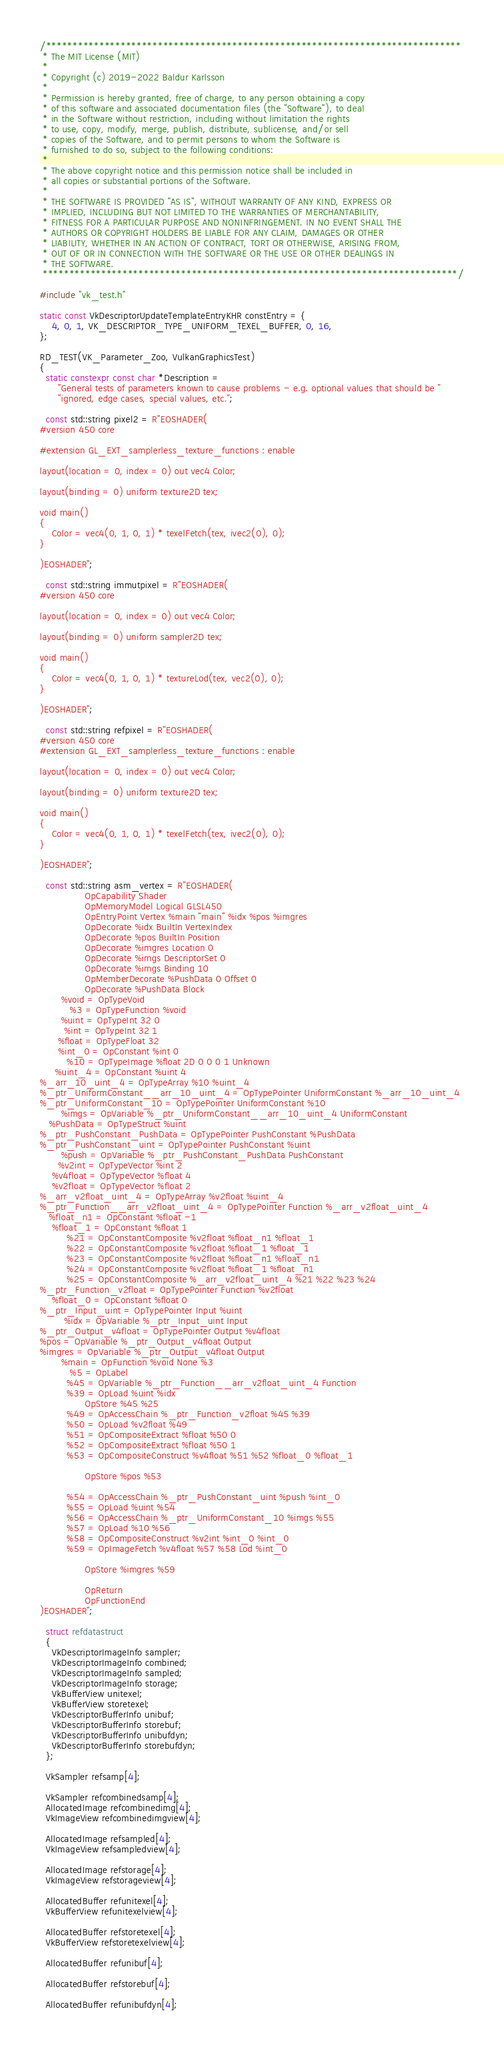<code> <loc_0><loc_0><loc_500><loc_500><_C++_>/******************************************************************************
 * The MIT License (MIT)
 *
 * Copyright (c) 2019-2022 Baldur Karlsson
 *
 * Permission is hereby granted, free of charge, to any person obtaining a copy
 * of this software and associated documentation files (the "Software"), to deal
 * in the Software without restriction, including without limitation the rights
 * to use, copy, modify, merge, publish, distribute, sublicense, and/or sell
 * copies of the Software, and to permit persons to whom the Software is
 * furnished to do so, subject to the following conditions:
 *
 * The above copyright notice and this permission notice shall be included in
 * all copies or substantial portions of the Software.
 *
 * THE SOFTWARE IS PROVIDED "AS IS", WITHOUT WARRANTY OF ANY KIND, EXPRESS OR
 * IMPLIED, INCLUDING BUT NOT LIMITED TO THE WARRANTIES OF MERCHANTABILITY,
 * FITNESS FOR A PARTICULAR PURPOSE AND NONINFRINGEMENT. IN NO EVENT SHALL THE
 * AUTHORS OR COPYRIGHT HOLDERS BE LIABLE FOR ANY CLAIM, DAMAGES OR OTHER
 * LIABILITY, WHETHER IN AN ACTION OF CONTRACT, TORT OR OTHERWISE, ARISING FROM,
 * OUT OF OR IN CONNECTION WITH THE SOFTWARE OR THE USE OR OTHER DEALINGS IN
 * THE SOFTWARE.
 ******************************************************************************/

#include "vk_test.h"

static const VkDescriptorUpdateTemplateEntryKHR constEntry = {
    4, 0, 1, VK_DESCRIPTOR_TYPE_UNIFORM_TEXEL_BUFFER, 0, 16,
};

RD_TEST(VK_Parameter_Zoo, VulkanGraphicsTest)
{
  static constexpr const char *Description =
      "General tests of parameters known to cause problems - e.g. optional values that should be "
      "ignored, edge cases, special values, etc.";

  const std::string pixel2 = R"EOSHADER(
#version 450 core

#extension GL_EXT_samplerless_texture_functions : enable

layout(location = 0, index = 0) out vec4 Color;

layout(binding = 0) uniform texture2D tex;

void main()
{
	Color = vec4(0, 1, 0, 1) * texelFetch(tex, ivec2(0), 0);
}

)EOSHADER";

  const std::string immutpixel = R"EOSHADER(
#version 450 core

layout(location = 0, index = 0) out vec4 Color;

layout(binding = 0) uniform sampler2D tex;

void main()
{
	Color = vec4(0, 1, 0, 1) * textureLod(tex, vec2(0), 0);
}

)EOSHADER";

  const std::string refpixel = R"EOSHADER(
#version 450 core
#extension GL_EXT_samplerless_texture_functions : enable

layout(location = 0, index = 0) out vec4 Color;

layout(binding = 0) uniform texture2D tex;

void main()
{
	Color = vec4(0, 1, 0, 1) * texelFetch(tex, ivec2(0), 0);
}

)EOSHADER";

  const std::string asm_vertex = R"EOSHADER(
               OpCapability Shader
               OpMemoryModel Logical GLSL450
               OpEntryPoint Vertex %main "main" %idx %pos %imgres
               OpDecorate %idx BuiltIn VertexIndex
               OpDecorate %pos BuiltIn Position
               OpDecorate %imgres Location 0
               OpDecorate %imgs DescriptorSet 0
               OpDecorate %imgs Binding 10
               OpMemberDecorate %PushData 0 Offset 0
               OpDecorate %PushData Block
       %void = OpTypeVoid
          %3 = OpTypeFunction %void
       %uint = OpTypeInt 32 0
        %int = OpTypeInt 32 1
      %float = OpTypeFloat 32
      %int_0 = OpConstant %int 0
         %10 = OpTypeImage %float 2D 0 0 0 1 Unknown
     %uint_4 = OpConstant %uint 4
%_arr_10_uint_4 = OpTypeArray %10 %uint_4
%_ptr_UniformConstant__arr_10_uint_4 = OpTypePointer UniformConstant %_arr_10_uint_4
%_ptr_UniformConstant_10 = OpTypePointer UniformConstant %10
       %imgs = OpVariable %_ptr_UniformConstant__arr_10_uint_4 UniformConstant
   %PushData = OpTypeStruct %uint
%_ptr_PushConstant_PushData = OpTypePointer PushConstant %PushData
%_ptr_PushConstant_uint = OpTypePointer PushConstant %uint
       %push = OpVariable %_ptr_PushConstant_PushData PushConstant
      %v2int = OpTypeVector %int 2
    %v4float = OpTypeVector %float 4
    %v2float = OpTypeVector %float 2
%_arr_v2float_uint_4 = OpTypeArray %v2float %uint_4
%_ptr_Function__arr_v2float_uint_4 = OpTypePointer Function %_arr_v2float_uint_4
   %float_n1 = OpConstant %float -1
    %float_1 = OpConstant %float 1
         %21 = OpConstantComposite %v2float %float_n1 %float_1
         %22 = OpConstantComposite %v2float %float_1 %float_1
         %23 = OpConstantComposite %v2float %float_n1 %float_n1
         %24 = OpConstantComposite %v2float %float_1 %float_n1
         %25 = OpConstantComposite %_arr_v2float_uint_4 %21 %22 %23 %24
%_ptr_Function_v2float = OpTypePointer Function %v2float
    %float_0 = OpConstant %float 0
%_ptr_Input_uint = OpTypePointer Input %uint
        %idx = OpVariable %_ptr_Input_uint Input
%_ptr_Output_v4float = OpTypePointer Output %v4float
%pos = OpVariable %_ptr_Output_v4float Output
%imgres = OpVariable %_ptr_Output_v4float Output
       %main = OpFunction %void None %3
          %5 = OpLabel
         %45 = OpVariable %_ptr_Function__arr_v2float_uint_4 Function
         %39 = OpLoad %uint %idx
               OpStore %45 %25
         %49 = OpAccessChain %_ptr_Function_v2float %45 %39
         %50 = OpLoad %v2float %49
         %51 = OpCompositeExtract %float %50 0
         %52 = OpCompositeExtract %float %50 1
         %53 = OpCompositeConstruct %v4float %51 %52 %float_0 %float_1

               OpStore %pos %53

         %54 = OpAccessChain %_ptr_PushConstant_uint %push %int_0
         %55 = OpLoad %uint %54
         %56 = OpAccessChain %_ptr_UniformConstant_10 %imgs %55
         %57 = OpLoad %10 %56
         %58 = OpCompositeConstruct %v2int %int_0 %int_0
         %59 = OpImageFetch %v4float %57 %58 Lod %int_0

               OpStore %imgres %59

               OpReturn
               OpFunctionEnd
)EOSHADER";

  struct refdatastruct
  {
    VkDescriptorImageInfo sampler;
    VkDescriptorImageInfo combined;
    VkDescriptorImageInfo sampled;
    VkDescriptorImageInfo storage;
    VkBufferView unitexel;
    VkBufferView storetexel;
    VkDescriptorBufferInfo unibuf;
    VkDescriptorBufferInfo storebuf;
    VkDescriptorBufferInfo unibufdyn;
    VkDescriptorBufferInfo storebufdyn;
  };

  VkSampler refsamp[4];

  VkSampler refcombinedsamp[4];
  AllocatedImage refcombinedimg[4];
  VkImageView refcombinedimgview[4];

  AllocatedImage refsampled[4];
  VkImageView refsampledview[4];

  AllocatedImage refstorage[4];
  VkImageView refstorageview[4];

  AllocatedBuffer refunitexel[4];
  VkBufferView refunitexelview[4];

  AllocatedBuffer refstoretexel[4];
  VkBufferView refstoretexelview[4];

  AllocatedBuffer refunibuf[4];

  AllocatedBuffer refstorebuf[4];

  AllocatedBuffer refunibufdyn[4];
</code> 